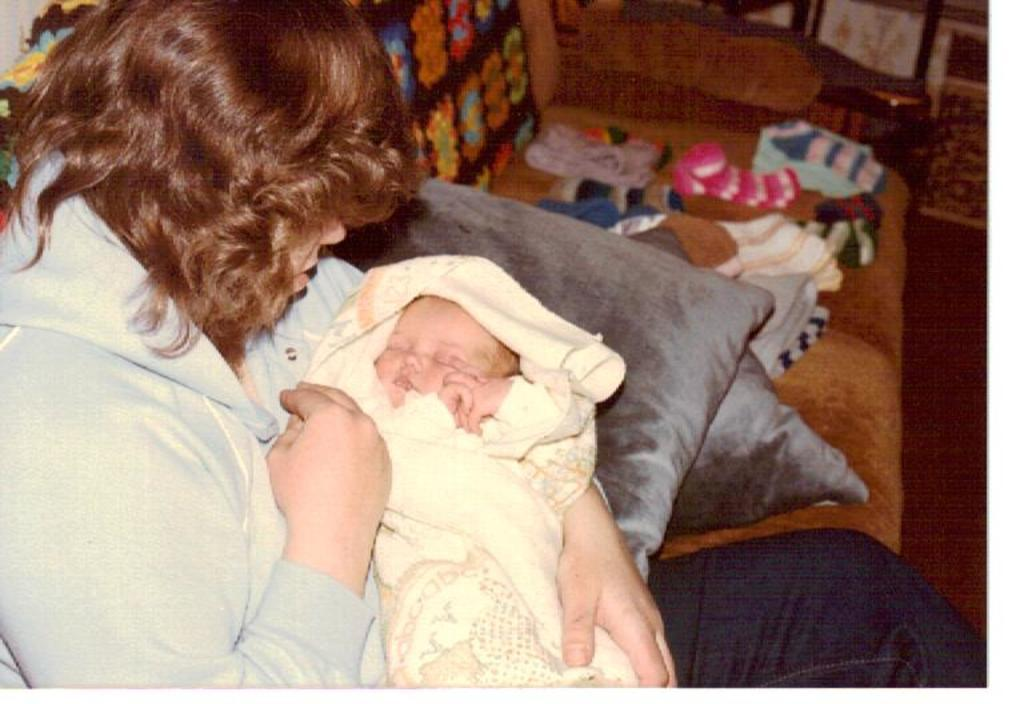What is the woman in the image doing? The woman is sitting in the image and holding a baby. What can be seen around the woman in the image? There are cushions visible in the image. What else is present on the furniture in the image? There are clothes on the couch. Where is the ring located in the image? There is no ring present in the image. What type of baby is depicted in the image? The image does not specify the type of baby; it only shows a baby being held by the woman. 